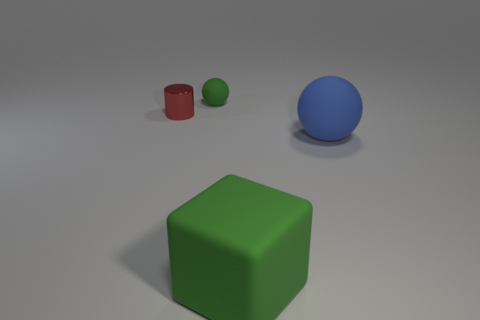Add 2 big brown metal cubes. How many objects exist? 6 Subtract all cubes. How many objects are left? 3 Subtract all green cylinders. Subtract all small cylinders. How many objects are left? 3 Add 4 rubber cubes. How many rubber cubes are left? 5 Add 4 purple metal objects. How many purple metal objects exist? 4 Subtract 0 brown spheres. How many objects are left? 4 